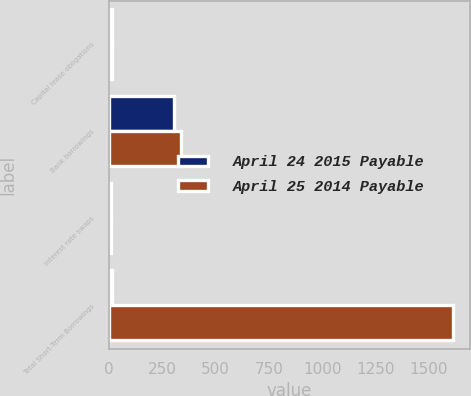<chart> <loc_0><loc_0><loc_500><loc_500><stacked_bar_chart><ecel><fcel>Capital lease obligations<fcel>Bank borrowings<fcel>Interest rate swaps<fcel>Total Short-Term Borrowings<nl><fcel>April 24 2015 Payable<fcel>16<fcel>303<fcel>10<fcel>16<nl><fcel>April 25 2014 Payable<fcel>14<fcel>337<fcel>12<fcel>1613<nl></chart> 